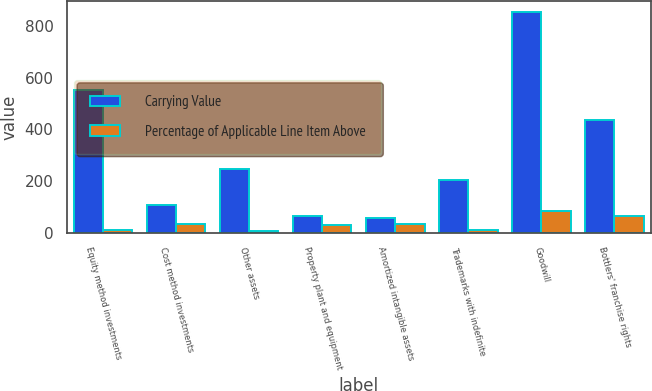Convert chart. <chart><loc_0><loc_0><loc_500><loc_500><stacked_bar_chart><ecel><fcel>Equity method investments<fcel>Cost method investments<fcel>Other assets<fcel>Property plant and equipment<fcel>Amortized intangible assets<fcel>Trademarks with indefinite<fcel>Goodwill<fcel>Bottlers' franchise rights<nl><fcel>Carrying Value<fcel>552<fcel>108<fcel>245<fcel>66<fcel>56<fcel>204<fcel>853<fcel>436<nl><fcel>Percentage of Applicable Line Item Above<fcel>11<fcel>34<fcel>7<fcel>30<fcel>34<fcel>10<fcel>83<fcel>66<nl></chart> 